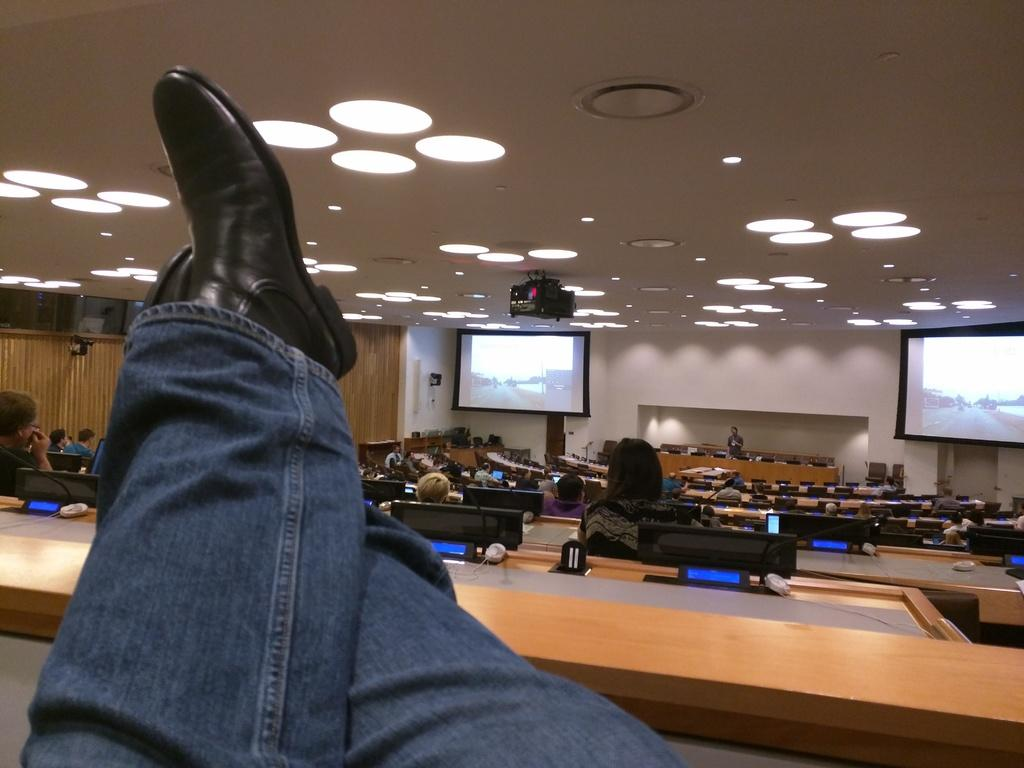What are the people in the image doing? The people in the image are sitting on benches. Can you describe any specific details about the people in the image? A leg and shoe are visible in the image. What can be seen in the background of the image? There are two projector screens in the background of the image. What type of plastic is being used to drive the projector screens in the image? There is no plastic or driving involved with the projector screens in the image; they are simply displaying images or videos. 